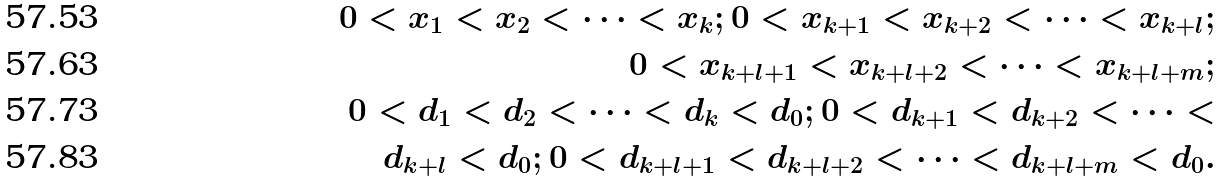Convert formula to latex. <formula><loc_0><loc_0><loc_500><loc_500>0 < x _ { 1 } < x _ { 2 } < \dots < x _ { k } ; 0 < x _ { k + 1 } < x _ { k + 2 } < \dots < x _ { k + l } ; \\ 0 < x _ { k + l + 1 } < x _ { k + l + 2 } < \dots < x _ { k + l + m } ; \\ 0 < d _ { 1 } < d _ { 2 } < \dots < d _ { k } < d _ { 0 } ; 0 < d _ { k + 1 } < d _ { k + 2 } < \dots < \\ d _ { k + l } < d _ { 0 } ; 0 < d _ { k + l + 1 } < d _ { k + l + 2 } < \dots < d _ { k + l + m } < d _ { 0 } .</formula> 